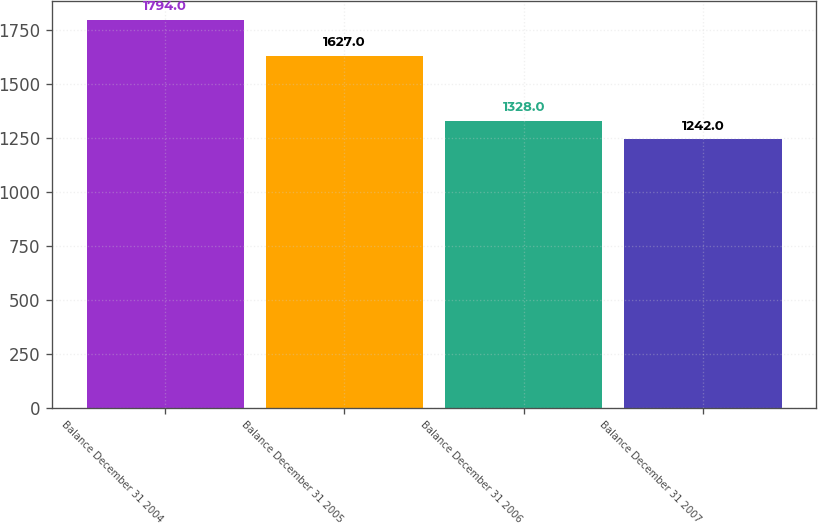Convert chart to OTSL. <chart><loc_0><loc_0><loc_500><loc_500><bar_chart><fcel>Balance December 31 2004<fcel>Balance December 31 2005<fcel>Balance December 31 2006<fcel>Balance December 31 2007<nl><fcel>1794<fcel>1627<fcel>1328<fcel>1242<nl></chart> 